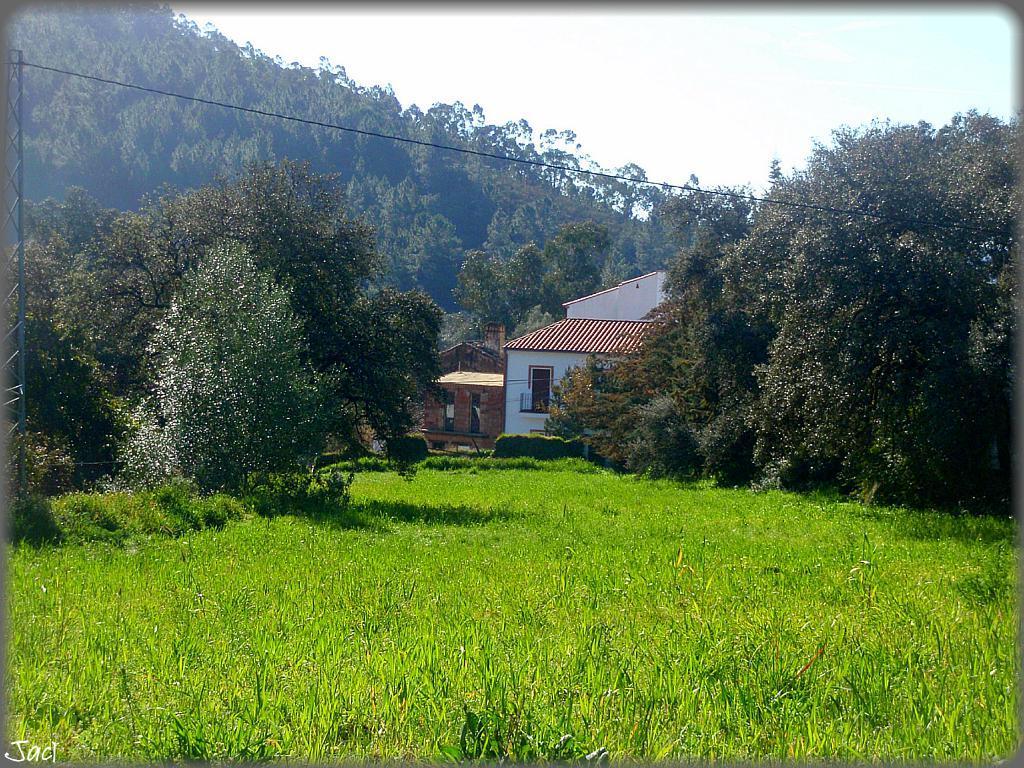Please provide a concise description of this image. These are trees and grass, this is house and grass. 